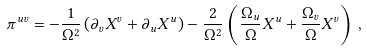<formula> <loc_0><loc_0><loc_500><loc_500>\pi ^ { u v } = - \frac { 1 } { \Omega ^ { 2 } } \left ( \partial _ { v } X ^ { v } + \partial _ { u } X ^ { u } \right ) - \frac { 2 } { \Omega ^ { 2 } } \left ( \frac { \Omega _ { u } } { \Omega } X ^ { u } + \frac { \Omega _ { v } } { \Omega } X ^ { v } \right ) \, ,</formula> 